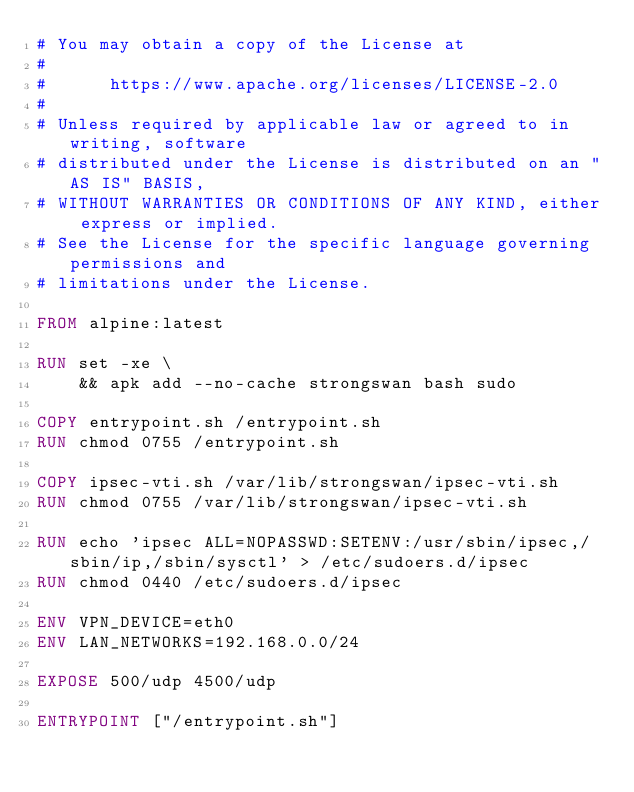Convert code to text. <code><loc_0><loc_0><loc_500><loc_500><_Dockerfile_># You may obtain a copy of the License at
#
#      https://www.apache.org/licenses/LICENSE-2.0
#
# Unless required by applicable law or agreed to in writing, software
# distributed under the License is distributed on an "AS IS" BASIS,
# WITHOUT WARRANTIES OR CONDITIONS OF ANY KIND, either express or implied.
# See the License for the specific language governing permissions and
# limitations under the License.

FROM alpine:latest

RUN set -xe \
    && apk add --no-cache strongswan bash sudo

COPY entrypoint.sh /entrypoint.sh
RUN chmod 0755 /entrypoint.sh

COPY ipsec-vti.sh /var/lib/strongswan/ipsec-vti.sh
RUN chmod 0755 /var/lib/strongswan/ipsec-vti.sh

RUN echo 'ipsec ALL=NOPASSWD:SETENV:/usr/sbin/ipsec,/sbin/ip,/sbin/sysctl' > /etc/sudoers.d/ipsec
RUN chmod 0440 /etc/sudoers.d/ipsec

ENV VPN_DEVICE=eth0
ENV LAN_NETWORKS=192.168.0.0/24

EXPOSE 500/udp 4500/udp

ENTRYPOINT ["/entrypoint.sh"]
</code> 